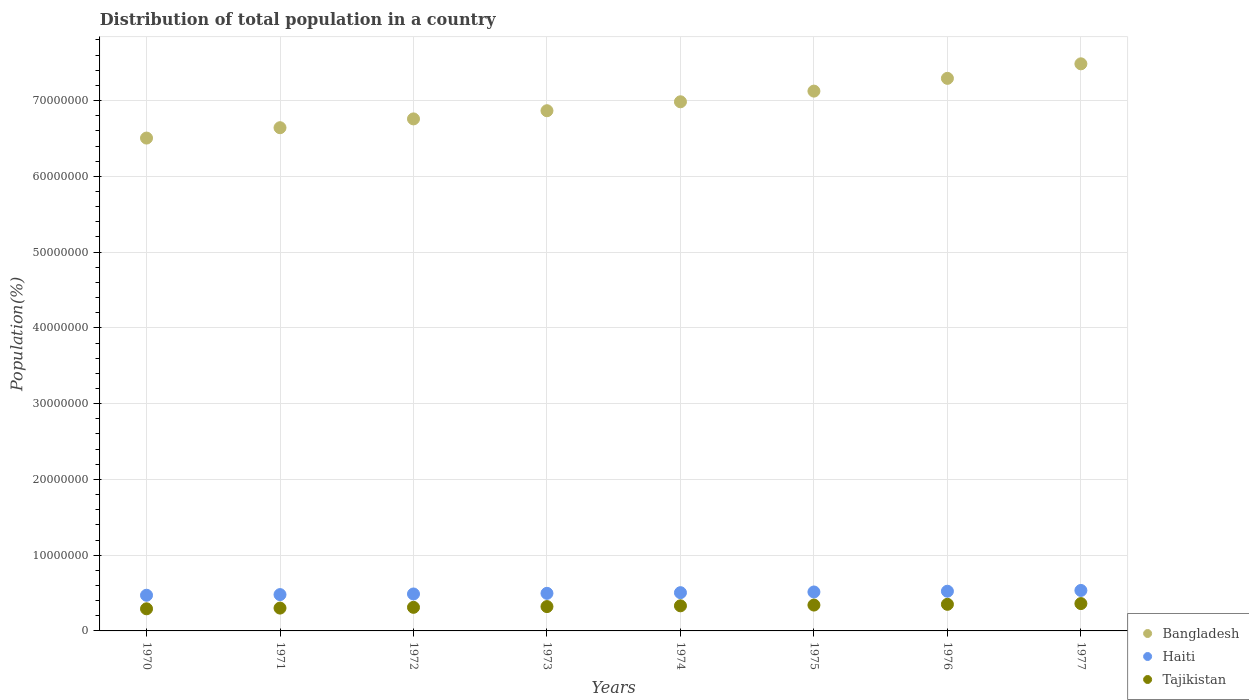How many different coloured dotlines are there?
Offer a very short reply. 3. Is the number of dotlines equal to the number of legend labels?
Offer a terse response. Yes. What is the population of in Tajikistan in 1970?
Keep it short and to the point. 2.92e+06. Across all years, what is the maximum population of in Bangladesh?
Make the answer very short. 7.48e+07. Across all years, what is the minimum population of in Bangladesh?
Your response must be concise. 6.50e+07. What is the total population of in Tajikistan in the graph?
Offer a very short reply. 2.61e+07. What is the difference between the population of in Bangladesh in 1973 and that in 1975?
Your response must be concise. -2.59e+06. What is the difference between the population of in Bangladesh in 1973 and the population of in Tajikistan in 1970?
Keep it short and to the point. 6.57e+07. What is the average population of in Bangladesh per year?
Make the answer very short. 6.96e+07. In the year 1974, what is the difference between the population of in Tajikistan and population of in Bangladesh?
Provide a short and direct response. -6.65e+07. What is the ratio of the population of in Bangladesh in 1972 to that in 1974?
Give a very brief answer. 0.97. What is the difference between the highest and the second highest population of in Bangladesh?
Your answer should be compact. 1.92e+06. What is the difference between the highest and the lowest population of in Tajikistan?
Provide a succinct answer. 6.89e+05. In how many years, is the population of in Haiti greater than the average population of in Haiti taken over all years?
Your answer should be very brief. 4. Is it the case that in every year, the sum of the population of in Tajikistan and population of in Haiti  is greater than the population of in Bangladesh?
Give a very brief answer. No. Is the population of in Haiti strictly less than the population of in Bangladesh over the years?
Keep it short and to the point. Yes. How many dotlines are there?
Your response must be concise. 3. What is the difference between two consecutive major ticks on the Y-axis?
Provide a short and direct response. 1.00e+07. Are the values on the major ticks of Y-axis written in scientific E-notation?
Keep it short and to the point. No. Does the graph contain any zero values?
Provide a succinct answer. No. What is the title of the graph?
Ensure brevity in your answer.  Distribution of total population in a country. Does "Philippines" appear as one of the legend labels in the graph?
Provide a short and direct response. No. What is the label or title of the Y-axis?
Provide a succinct answer. Population(%). What is the Population(%) of Bangladesh in 1970?
Your answer should be very brief. 6.50e+07. What is the Population(%) in Haiti in 1970?
Make the answer very short. 4.71e+06. What is the Population(%) of Tajikistan in 1970?
Ensure brevity in your answer.  2.92e+06. What is the Population(%) in Bangladesh in 1971?
Your response must be concise. 6.64e+07. What is the Population(%) of Haiti in 1971?
Your answer should be very brief. 4.79e+06. What is the Population(%) in Tajikistan in 1971?
Give a very brief answer. 3.01e+06. What is the Population(%) of Bangladesh in 1972?
Make the answer very short. 6.76e+07. What is the Population(%) in Haiti in 1972?
Keep it short and to the point. 4.88e+06. What is the Population(%) of Tajikistan in 1972?
Provide a succinct answer. 3.11e+06. What is the Population(%) in Bangladesh in 1973?
Make the answer very short. 6.87e+07. What is the Population(%) in Haiti in 1973?
Ensure brevity in your answer.  4.96e+06. What is the Population(%) of Tajikistan in 1973?
Keep it short and to the point. 3.21e+06. What is the Population(%) of Bangladesh in 1974?
Keep it short and to the point. 6.98e+07. What is the Population(%) in Haiti in 1974?
Offer a terse response. 5.05e+06. What is the Population(%) in Tajikistan in 1974?
Offer a very short reply. 3.31e+06. What is the Population(%) of Bangladesh in 1975?
Keep it short and to the point. 7.12e+07. What is the Population(%) in Haiti in 1975?
Offer a very short reply. 5.14e+06. What is the Population(%) of Tajikistan in 1975?
Offer a terse response. 3.41e+06. What is the Population(%) of Bangladesh in 1976?
Provide a succinct answer. 7.29e+07. What is the Population(%) of Haiti in 1976?
Your answer should be compact. 5.24e+06. What is the Population(%) in Tajikistan in 1976?
Give a very brief answer. 3.51e+06. What is the Population(%) in Bangladesh in 1977?
Offer a terse response. 7.48e+07. What is the Population(%) of Haiti in 1977?
Give a very brief answer. 5.34e+06. What is the Population(%) of Tajikistan in 1977?
Ensure brevity in your answer.  3.61e+06. Across all years, what is the maximum Population(%) of Bangladesh?
Give a very brief answer. 7.48e+07. Across all years, what is the maximum Population(%) in Haiti?
Your answer should be very brief. 5.34e+06. Across all years, what is the maximum Population(%) in Tajikistan?
Your answer should be compact. 3.61e+06. Across all years, what is the minimum Population(%) in Bangladesh?
Keep it short and to the point. 6.50e+07. Across all years, what is the minimum Population(%) in Haiti?
Make the answer very short. 4.71e+06. Across all years, what is the minimum Population(%) in Tajikistan?
Offer a very short reply. 2.92e+06. What is the total Population(%) of Bangladesh in the graph?
Keep it short and to the point. 5.57e+08. What is the total Population(%) in Haiti in the graph?
Provide a short and direct response. 4.01e+07. What is the total Population(%) of Tajikistan in the graph?
Offer a very short reply. 2.61e+07. What is the difference between the Population(%) in Bangladesh in 1970 and that in 1971?
Offer a very short reply. -1.37e+06. What is the difference between the Population(%) of Haiti in 1970 and that in 1971?
Make the answer very short. -8.45e+04. What is the difference between the Population(%) of Tajikistan in 1970 and that in 1971?
Your response must be concise. -9.44e+04. What is the difference between the Population(%) in Bangladesh in 1970 and that in 1972?
Offer a very short reply. -2.53e+06. What is the difference between the Population(%) in Haiti in 1970 and that in 1972?
Provide a succinct answer. -1.68e+05. What is the difference between the Population(%) of Tajikistan in 1970 and that in 1972?
Make the answer very short. -1.92e+05. What is the difference between the Population(%) of Bangladesh in 1970 and that in 1973?
Ensure brevity in your answer.  -3.61e+06. What is the difference between the Population(%) in Haiti in 1970 and that in 1973?
Your answer should be very brief. -2.52e+05. What is the difference between the Population(%) in Tajikistan in 1970 and that in 1973?
Provide a short and direct response. -2.93e+05. What is the difference between the Population(%) in Bangladesh in 1970 and that in 1974?
Provide a short and direct response. -4.79e+06. What is the difference between the Population(%) of Haiti in 1970 and that in 1974?
Provide a succinct answer. -3.39e+05. What is the difference between the Population(%) of Tajikistan in 1970 and that in 1974?
Provide a succinct answer. -3.94e+05. What is the difference between the Population(%) in Bangladesh in 1970 and that in 1975?
Provide a succinct answer. -6.20e+06. What is the difference between the Population(%) of Haiti in 1970 and that in 1975?
Give a very brief answer. -4.32e+05. What is the difference between the Population(%) in Tajikistan in 1970 and that in 1975?
Your answer should be compact. -4.93e+05. What is the difference between the Population(%) in Bangladesh in 1970 and that in 1976?
Your answer should be compact. -7.88e+06. What is the difference between the Population(%) of Haiti in 1970 and that in 1976?
Offer a very short reply. -5.30e+05. What is the difference between the Population(%) of Tajikistan in 1970 and that in 1976?
Your answer should be very brief. -5.91e+05. What is the difference between the Population(%) of Bangladesh in 1970 and that in 1977?
Give a very brief answer. -9.80e+06. What is the difference between the Population(%) in Haiti in 1970 and that in 1977?
Provide a short and direct response. -6.33e+05. What is the difference between the Population(%) in Tajikistan in 1970 and that in 1977?
Give a very brief answer. -6.89e+05. What is the difference between the Population(%) in Bangladesh in 1971 and that in 1972?
Offer a terse response. -1.16e+06. What is the difference between the Population(%) in Haiti in 1971 and that in 1972?
Make the answer very short. -8.34e+04. What is the difference between the Population(%) of Tajikistan in 1971 and that in 1972?
Keep it short and to the point. -9.81e+04. What is the difference between the Population(%) of Bangladesh in 1971 and that in 1973?
Your answer should be compact. -2.24e+06. What is the difference between the Population(%) of Haiti in 1971 and that in 1973?
Ensure brevity in your answer.  -1.67e+05. What is the difference between the Population(%) of Tajikistan in 1971 and that in 1973?
Provide a succinct answer. -1.98e+05. What is the difference between the Population(%) in Bangladesh in 1971 and that in 1974?
Offer a very short reply. -3.42e+06. What is the difference between the Population(%) in Haiti in 1971 and that in 1974?
Give a very brief answer. -2.55e+05. What is the difference between the Population(%) in Tajikistan in 1971 and that in 1974?
Offer a very short reply. -2.99e+05. What is the difference between the Population(%) of Bangladesh in 1971 and that in 1975?
Offer a very short reply. -4.83e+06. What is the difference between the Population(%) of Haiti in 1971 and that in 1975?
Your answer should be compact. -3.47e+05. What is the difference between the Population(%) of Tajikistan in 1971 and that in 1975?
Provide a succinct answer. -3.99e+05. What is the difference between the Population(%) in Bangladesh in 1971 and that in 1976?
Offer a very short reply. -6.51e+06. What is the difference between the Population(%) of Haiti in 1971 and that in 1976?
Give a very brief answer. -4.45e+05. What is the difference between the Population(%) in Tajikistan in 1971 and that in 1976?
Your answer should be very brief. -4.97e+05. What is the difference between the Population(%) in Bangladesh in 1971 and that in 1977?
Provide a succinct answer. -8.43e+06. What is the difference between the Population(%) in Haiti in 1971 and that in 1977?
Your answer should be compact. -5.48e+05. What is the difference between the Population(%) of Tajikistan in 1971 and that in 1977?
Offer a very short reply. -5.95e+05. What is the difference between the Population(%) in Bangladesh in 1972 and that in 1973?
Make the answer very short. -1.08e+06. What is the difference between the Population(%) of Haiti in 1972 and that in 1973?
Keep it short and to the point. -8.41e+04. What is the difference between the Population(%) of Tajikistan in 1972 and that in 1973?
Make the answer very short. -1.00e+05. What is the difference between the Population(%) in Bangladesh in 1972 and that in 1974?
Provide a succinct answer. -2.26e+06. What is the difference between the Population(%) in Haiti in 1972 and that in 1974?
Offer a terse response. -1.71e+05. What is the difference between the Population(%) of Tajikistan in 1972 and that in 1974?
Offer a terse response. -2.01e+05. What is the difference between the Population(%) in Bangladesh in 1972 and that in 1975?
Offer a very short reply. -3.67e+06. What is the difference between the Population(%) in Haiti in 1972 and that in 1975?
Your answer should be compact. -2.64e+05. What is the difference between the Population(%) in Tajikistan in 1972 and that in 1975?
Keep it short and to the point. -3.01e+05. What is the difference between the Population(%) of Bangladesh in 1972 and that in 1976?
Provide a succinct answer. -5.35e+06. What is the difference between the Population(%) in Haiti in 1972 and that in 1976?
Offer a very short reply. -3.62e+05. What is the difference between the Population(%) in Tajikistan in 1972 and that in 1976?
Give a very brief answer. -3.99e+05. What is the difference between the Population(%) in Bangladesh in 1972 and that in 1977?
Your answer should be compact. -7.27e+06. What is the difference between the Population(%) of Haiti in 1972 and that in 1977?
Give a very brief answer. -4.65e+05. What is the difference between the Population(%) of Tajikistan in 1972 and that in 1977?
Offer a terse response. -4.97e+05. What is the difference between the Population(%) of Bangladesh in 1973 and that in 1974?
Offer a very short reply. -1.18e+06. What is the difference between the Population(%) in Haiti in 1973 and that in 1974?
Your answer should be very brief. -8.73e+04. What is the difference between the Population(%) in Tajikistan in 1973 and that in 1974?
Your response must be concise. -1.01e+05. What is the difference between the Population(%) in Bangladesh in 1973 and that in 1975?
Offer a terse response. -2.59e+06. What is the difference between the Population(%) in Haiti in 1973 and that in 1975?
Provide a succinct answer. -1.80e+05. What is the difference between the Population(%) of Tajikistan in 1973 and that in 1975?
Make the answer very short. -2.00e+05. What is the difference between the Population(%) of Bangladesh in 1973 and that in 1976?
Your response must be concise. -4.27e+06. What is the difference between the Population(%) in Haiti in 1973 and that in 1976?
Your answer should be compact. -2.78e+05. What is the difference between the Population(%) in Tajikistan in 1973 and that in 1976?
Give a very brief answer. -2.99e+05. What is the difference between the Population(%) of Bangladesh in 1973 and that in 1977?
Ensure brevity in your answer.  -6.19e+06. What is the difference between the Population(%) of Haiti in 1973 and that in 1977?
Provide a short and direct response. -3.81e+05. What is the difference between the Population(%) of Tajikistan in 1973 and that in 1977?
Give a very brief answer. -3.96e+05. What is the difference between the Population(%) of Bangladesh in 1974 and that in 1975?
Make the answer very short. -1.41e+06. What is the difference between the Population(%) of Haiti in 1974 and that in 1975?
Your answer should be very brief. -9.24e+04. What is the difference between the Population(%) of Tajikistan in 1974 and that in 1975?
Offer a terse response. -9.97e+04. What is the difference between the Population(%) of Bangladesh in 1974 and that in 1976?
Ensure brevity in your answer.  -3.09e+06. What is the difference between the Population(%) in Haiti in 1974 and that in 1976?
Keep it short and to the point. -1.90e+05. What is the difference between the Population(%) in Tajikistan in 1974 and that in 1976?
Provide a short and direct response. -1.98e+05. What is the difference between the Population(%) in Bangladesh in 1974 and that in 1977?
Your response must be concise. -5.01e+06. What is the difference between the Population(%) of Haiti in 1974 and that in 1977?
Give a very brief answer. -2.93e+05. What is the difference between the Population(%) of Tajikistan in 1974 and that in 1977?
Give a very brief answer. -2.96e+05. What is the difference between the Population(%) in Bangladesh in 1975 and that in 1976?
Your response must be concise. -1.68e+06. What is the difference between the Population(%) of Haiti in 1975 and that in 1976?
Provide a succinct answer. -9.79e+04. What is the difference between the Population(%) of Tajikistan in 1975 and that in 1976?
Make the answer very short. -9.82e+04. What is the difference between the Population(%) in Bangladesh in 1975 and that in 1977?
Your answer should be very brief. -3.60e+06. What is the difference between the Population(%) of Haiti in 1975 and that in 1977?
Offer a terse response. -2.01e+05. What is the difference between the Population(%) in Tajikistan in 1975 and that in 1977?
Offer a very short reply. -1.96e+05. What is the difference between the Population(%) of Bangladesh in 1976 and that in 1977?
Your answer should be very brief. -1.92e+06. What is the difference between the Population(%) of Haiti in 1976 and that in 1977?
Offer a very short reply. -1.03e+05. What is the difference between the Population(%) of Tajikistan in 1976 and that in 1977?
Offer a terse response. -9.77e+04. What is the difference between the Population(%) of Bangladesh in 1970 and the Population(%) of Haiti in 1971?
Make the answer very short. 6.03e+07. What is the difference between the Population(%) in Bangladesh in 1970 and the Population(%) in Tajikistan in 1971?
Ensure brevity in your answer.  6.20e+07. What is the difference between the Population(%) in Haiti in 1970 and the Population(%) in Tajikistan in 1971?
Your answer should be compact. 1.69e+06. What is the difference between the Population(%) in Bangladesh in 1970 and the Population(%) in Haiti in 1972?
Ensure brevity in your answer.  6.02e+07. What is the difference between the Population(%) of Bangladesh in 1970 and the Population(%) of Tajikistan in 1972?
Give a very brief answer. 6.19e+07. What is the difference between the Population(%) of Haiti in 1970 and the Population(%) of Tajikistan in 1972?
Offer a very short reply. 1.60e+06. What is the difference between the Population(%) of Bangladesh in 1970 and the Population(%) of Haiti in 1973?
Offer a terse response. 6.01e+07. What is the difference between the Population(%) in Bangladesh in 1970 and the Population(%) in Tajikistan in 1973?
Provide a short and direct response. 6.18e+07. What is the difference between the Population(%) in Haiti in 1970 and the Population(%) in Tajikistan in 1973?
Give a very brief answer. 1.50e+06. What is the difference between the Population(%) of Bangladesh in 1970 and the Population(%) of Haiti in 1974?
Offer a very short reply. 6.00e+07. What is the difference between the Population(%) of Bangladesh in 1970 and the Population(%) of Tajikistan in 1974?
Provide a succinct answer. 6.17e+07. What is the difference between the Population(%) in Haiti in 1970 and the Population(%) in Tajikistan in 1974?
Offer a very short reply. 1.40e+06. What is the difference between the Population(%) in Bangladesh in 1970 and the Population(%) in Haiti in 1975?
Make the answer very short. 5.99e+07. What is the difference between the Population(%) in Bangladesh in 1970 and the Population(%) in Tajikistan in 1975?
Keep it short and to the point. 6.16e+07. What is the difference between the Population(%) of Haiti in 1970 and the Population(%) of Tajikistan in 1975?
Your response must be concise. 1.30e+06. What is the difference between the Population(%) in Bangladesh in 1970 and the Population(%) in Haiti in 1976?
Ensure brevity in your answer.  5.98e+07. What is the difference between the Population(%) in Bangladesh in 1970 and the Population(%) in Tajikistan in 1976?
Ensure brevity in your answer.  6.15e+07. What is the difference between the Population(%) in Haiti in 1970 and the Population(%) in Tajikistan in 1976?
Offer a terse response. 1.20e+06. What is the difference between the Population(%) of Bangladesh in 1970 and the Population(%) of Haiti in 1977?
Ensure brevity in your answer.  5.97e+07. What is the difference between the Population(%) in Bangladesh in 1970 and the Population(%) in Tajikistan in 1977?
Offer a very short reply. 6.14e+07. What is the difference between the Population(%) in Haiti in 1970 and the Population(%) in Tajikistan in 1977?
Offer a terse response. 1.10e+06. What is the difference between the Population(%) of Bangladesh in 1971 and the Population(%) of Haiti in 1972?
Your answer should be very brief. 6.15e+07. What is the difference between the Population(%) in Bangladesh in 1971 and the Population(%) in Tajikistan in 1972?
Keep it short and to the point. 6.33e+07. What is the difference between the Population(%) of Haiti in 1971 and the Population(%) of Tajikistan in 1972?
Keep it short and to the point. 1.68e+06. What is the difference between the Population(%) of Bangladesh in 1971 and the Population(%) of Haiti in 1973?
Your answer should be very brief. 6.15e+07. What is the difference between the Population(%) of Bangladesh in 1971 and the Population(%) of Tajikistan in 1973?
Keep it short and to the point. 6.32e+07. What is the difference between the Population(%) in Haiti in 1971 and the Population(%) in Tajikistan in 1973?
Your answer should be very brief. 1.58e+06. What is the difference between the Population(%) in Bangladesh in 1971 and the Population(%) in Haiti in 1974?
Give a very brief answer. 6.14e+07. What is the difference between the Population(%) of Bangladesh in 1971 and the Population(%) of Tajikistan in 1974?
Your answer should be compact. 6.31e+07. What is the difference between the Population(%) of Haiti in 1971 and the Population(%) of Tajikistan in 1974?
Your answer should be compact. 1.48e+06. What is the difference between the Population(%) of Bangladesh in 1971 and the Population(%) of Haiti in 1975?
Give a very brief answer. 6.13e+07. What is the difference between the Population(%) in Bangladesh in 1971 and the Population(%) in Tajikistan in 1975?
Offer a terse response. 6.30e+07. What is the difference between the Population(%) of Haiti in 1971 and the Population(%) of Tajikistan in 1975?
Keep it short and to the point. 1.38e+06. What is the difference between the Population(%) of Bangladesh in 1971 and the Population(%) of Haiti in 1976?
Make the answer very short. 6.12e+07. What is the difference between the Population(%) in Bangladesh in 1971 and the Population(%) in Tajikistan in 1976?
Keep it short and to the point. 6.29e+07. What is the difference between the Population(%) of Haiti in 1971 and the Population(%) of Tajikistan in 1976?
Your answer should be compact. 1.28e+06. What is the difference between the Population(%) in Bangladesh in 1971 and the Population(%) in Haiti in 1977?
Offer a very short reply. 6.11e+07. What is the difference between the Population(%) of Bangladesh in 1971 and the Population(%) of Tajikistan in 1977?
Your answer should be very brief. 6.28e+07. What is the difference between the Population(%) of Haiti in 1971 and the Population(%) of Tajikistan in 1977?
Give a very brief answer. 1.18e+06. What is the difference between the Population(%) of Bangladesh in 1972 and the Population(%) of Haiti in 1973?
Make the answer very short. 6.26e+07. What is the difference between the Population(%) in Bangladesh in 1972 and the Population(%) in Tajikistan in 1973?
Make the answer very short. 6.44e+07. What is the difference between the Population(%) in Haiti in 1972 and the Population(%) in Tajikistan in 1973?
Provide a succinct answer. 1.66e+06. What is the difference between the Population(%) of Bangladesh in 1972 and the Population(%) of Haiti in 1974?
Your answer should be very brief. 6.25e+07. What is the difference between the Population(%) of Bangladesh in 1972 and the Population(%) of Tajikistan in 1974?
Your response must be concise. 6.43e+07. What is the difference between the Population(%) in Haiti in 1972 and the Population(%) in Tajikistan in 1974?
Offer a terse response. 1.56e+06. What is the difference between the Population(%) of Bangladesh in 1972 and the Population(%) of Haiti in 1975?
Offer a very short reply. 6.24e+07. What is the difference between the Population(%) in Bangladesh in 1972 and the Population(%) in Tajikistan in 1975?
Ensure brevity in your answer.  6.42e+07. What is the difference between the Population(%) in Haiti in 1972 and the Population(%) in Tajikistan in 1975?
Your response must be concise. 1.46e+06. What is the difference between the Population(%) in Bangladesh in 1972 and the Population(%) in Haiti in 1976?
Ensure brevity in your answer.  6.23e+07. What is the difference between the Population(%) in Bangladesh in 1972 and the Population(%) in Tajikistan in 1976?
Your answer should be compact. 6.41e+07. What is the difference between the Population(%) in Haiti in 1972 and the Population(%) in Tajikistan in 1976?
Make the answer very short. 1.37e+06. What is the difference between the Population(%) of Bangladesh in 1972 and the Population(%) of Haiti in 1977?
Ensure brevity in your answer.  6.22e+07. What is the difference between the Population(%) in Bangladesh in 1972 and the Population(%) in Tajikistan in 1977?
Provide a succinct answer. 6.40e+07. What is the difference between the Population(%) in Haiti in 1972 and the Population(%) in Tajikistan in 1977?
Your answer should be very brief. 1.27e+06. What is the difference between the Population(%) of Bangladesh in 1973 and the Population(%) of Haiti in 1974?
Offer a very short reply. 6.36e+07. What is the difference between the Population(%) in Bangladesh in 1973 and the Population(%) in Tajikistan in 1974?
Your answer should be very brief. 6.53e+07. What is the difference between the Population(%) of Haiti in 1973 and the Population(%) of Tajikistan in 1974?
Ensure brevity in your answer.  1.65e+06. What is the difference between the Population(%) in Bangladesh in 1973 and the Population(%) in Haiti in 1975?
Provide a short and direct response. 6.35e+07. What is the difference between the Population(%) of Bangladesh in 1973 and the Population(%) of Tajikistan in 1975?
Offer a terse response. 6.52e+07. What is the difference between the Population(%) of Haiti in 1973 and the Population(%) of Tajikistan in 1975?
Offer a terse response. 1.55e+06. What is the difference between the Population(%) of Bangladesh in 1973 and the Population(%) of Haiti in 1976?
Keep it short and to the point. 6.34e+07. What is the difference between the Population(%) of Bangladesh in 1973 and the Population(%) of Tajikistan in 1976?
Ensure brevity in your answer.  6.51e+07. What is the difference between the Population(%) of Haiti in 1973 and the Population(%) of Tajikistan in 1976?
Your response must be concise. 1.45e+06. What is the difference between the Population(%) of Bangladesh in 1973 and the Population(%) of Haiti in 1977?
Provide a short and direct response. 6.33e+07. What is the difference between the Population(%) of Bangladesh in 1973 and the Population(%) of Tajikistan in 1977?
Offer a terse response. 6.50e+07. What is the difference between the Population(%) of Haiti in 1973 and the Population(%) of Tajikistan in 1977?
Make the answer very short. 1.35e+06. What is the difference between the Population(%) of Bangladesh in 1974 and the Population(%) of Haiti in 1975?
Your answer should be very brief. 6.47e+07. What is the difference between the Population(%) of Bangladesh in 1974 and the Population(%) of Tajikistan in 1975?
Your answer should be very brief. 6.64e+07. What is the difference between the Population(%) of Haiti in 1974 and the Population(%) of Tajikistan in 1975?
Ensure brevity in your answer.  1.64e+06. What is the difference between the Population(%) in Bangladesh in 1974 and the Population(%) in Haiti in 1976?
Your response must be concise. 6.46e+07. What is the difference between the Population(%) of Bangladesh in 1974 and the Population(%) of Tajikistan in 1976?
Your answer should be compact. 6.63e+07. What is the difference between the Population(%) of Haiti in 1974 and the Population(%) of Tajikistan in 1976?
Keep it short and to the point. 1.54e+06. What is the difference between the Population(%) of Bangladesh in 1974 and the Population(%) of Haiti in 1977?
Keep it short and to the point. 6.45e+07. What is the difference between the Population(%) of Bangladesh in 1974 and the Population(%) of Tajikistan in 1977?
Provide a short and direct response. 6.62e+07. What is the difference between the Population(%) of Haiti in 1974 and the Population(%) of Tajikistan in 1977?
Ensure brevity in your answer.  1.44e+06. What is the difference between the Population(%) in Bangladesh in 1975 and the Population(%) in Haiti in 1976?
Your response must be concise. 6.60e+07. What is the difference between the Population(%) of Bangladesh in 1975 and the Population(%) of Tajikistan in 1976?
Your answer should be very brief. 6.77e+07. What is the difference between the Population(%) in Haiti in 1975 and the Population(%) in Tajikistan in 1976?
Make the answer very short. 1.63e+06. What is the difference between the Population(%) in Bangladesh in 1975 and the Population(%) in Haiti in 1977?
Provide a succinct answer. 6.59e+07. What is the difference between the Population(%) of Bangladesh in 1975 and the Population(%) of Tajikistan in 1977?
Provide a short and direct response. 6.76e+07. What is the difference between the Population(%) in Haiti in 1975 and the Population(%) in Tajikistan in 1977?
Keep it short and to the point. 1.53e+06. What is the difference between the Population(%) in Bangladesh in 1976 and the Population(%) in Haiti in 1977?
Your response must be concise. 6.76e+07. What is the difference between the Population(%) of Bangladesh in 1976 and the Population(%) of Tajikistan in 1977?
Offer a terse response. 6.93e+07. What is the difference between the Population(%) of Haiti in 1976 and the Population(%) of Tajikistan in 1977?
Your response must be concise. 1.63e+06. What is the average Population(%) of Bangladesh per year?
Your answer should be compact. 6.96e+07. What is the average Population(%) in Haiti per year?
Ensure brevity in your answer.  5.01e+06. What is the average Population(%) in Tajikistan per year?
Ensure brevity in your answer.  3.26e+06. In the year 1970, what is the difference between the Population(%) in Bangladesh and Population(%) in Haiti?
Keep it short and to the point. 6.03e+07. In the year 1970, what is the difference between the Population(%) in Bangladesh and Population(%) in Tajikistan?
Keep it short and to the point. 6.21e+07. In the year 1970, what is the difference between the Population(%) in Haiti and Population(%) in Tajikistan?
Offer a very short reply. 1.79e+06. In the year 1971, what is the difference between the Population(%) in Bangladesh and Population(%) in Haiti?
Provide a succinct answer. 6.16e+07. In the year 1971, what is the difference between the Population(%) in Bangladesh and Population(%) in Tajikistan?
Keep it short and to the point. 6.34e+07. In the year 1971, what is the difference between the Population(%) of Haiti and Population(%) of Tajikistan?
Provide a short and direct response. 1.78e+06. In the year 1972, what is the difference between the Population(%) of Bangladesh and Population(%) of Haiti?
Your answer should be compact. 6.27e+07. In the year 1972, what is the difference between the Population(%) in Bangladesh and Population(%) in Tajikistan?
Your answer should be very brief. 6.45e+07. In the year 1972, what is the difference between the Population(%) in Haiti and Population(%) in Tajikistan?
Your answer should be very brief. 1.76e+06. In the year 1973, what is the difference between the Population(%) in Bangladesh and Population(%) in Haiti?
Offer a very short reply. 6.37e+07. In the year 1973, what is the difference between the Population(%) in Bangladesh and Population(%) in Tajikistan?
Your response must be concise. 6.54e+07. In the year 1973, what is the difference between the Population(%) in Haiti and Population(%) in Tajikistan?
Provide a short and direct response. 1.75e+06. In the year 1974, what is the difference between the Population(%) in Bangladesh and Population(%) in Haiti?
Provide a short and direct response. 6.48e+07. In the year 1974, what is the difference between the Population(%) in Bangladesh and Population(%) in Tajikistan?
Offer a terse response. 6.65e+07. In the year 1974, what is the difference between the Population(%) in Haiti and Population(%) in Tajikistan?
Give a very brief answer. 1.73e+06. In the year 1975, what is the difference between the Population(%) in Bangladesh and Population(%) in Haiti?
Your answer should be very brief. 6.61e+07. In the year 1975, what is the difference between the Population(%) in Bangladesh and Population(%) in Tajikistan?
Your answer should be compact. 6.78e+07. In the year 1975, what is the difference between the Population(%) in Haiti and Population(%) in Tajikistan?
Your answer should be compact. 1.73e+06. In the year 1976, what is the difference between the Population(%) in Bangladesh and Population(%) in Haiti?
Offer a terse response. 6.77e+07. In the year 1976, what is the difference between the Population(%) in Bangladesh and Population(%) in Tajikistan?
Ensure brevity in your answer.  6.94e+07. In the year 1976, what is the difference between the Population(%) of Haiti and Population(%) of Tajikistan?
Provide a succinct answer. 1.73e+06. In the year 1977, what is the difference between the Population(%) in Bangladesh and Population(%) in Haiti?
Offer a very short reply. 6.95e+07. In the year 1977, what is the difference between the Population(%) of Bangladesh and Population(%) of Tajikistan?
Offer a terse response. 7.12e+07. In the year 1977, what is the difference between the Population(%) in Haiti and Population(%) in Tajikistan?
Provide a succinct answer. 1.73e+06. What is the ratio of the Population(%) of Bangladesh in 1970 to that in 1971?
Your response must be concise. 0.98. What is the ratio of the Population(%) in Haiti in 1970 to that in 1971?
Ensure brevity in your answer.  0.98. What is the ratio of the Population(%) of Tajikistan in 1970 to that in 1971?
Your answer should be very brief. 0.97. What is the ratio of the Population(%) of Bangladesh in 1970 to that in 1972?
Provide a succinct answer. 0.96. What is the ratio of the Population(%) in Haiti in 1970 to that in 1972?
Offer a very short reply. 0.97. What is the ratio of the Population(%) of Tajikistan in 1970 to that in 1972?
Provide a short and direct response. 0.94. What is the ratio of the Population(%) of Bangladesh in 1970 to that in 1973?
Your answer should be very brief. 0.95. What is the ratio of the Population(%) of Haiti in 1970 to that in 1973?
Your answer should be compact. 0.95. What is the ratio of the Population(%) in Tajikistan in 1970 to that in 1973?
Offer a very short reply. 0.91. What is the ratio of the Population(%) of Bangladesh in 1970 to that in 1974?
Your answer should be very brief. 0.93. What is the ratio of the Population(%) in Haiti in 1970 to that in 1974?
Your response must be concise. 0.93. What is the ratio of the Population(%) of Tajikistan in 1970 to that in 1974?
Offer a terse response. 0.88. What is the ratio of the Population(%) in Haiti in 1970 to that in 1975?
Offer a very short reply. 0.92. What is the ratio of the Population(%) in Tajikistan in 1970 to that in 1975?
Give a very brief answer. 0.86. What is the ratio of the Population(%) in Bangladesh in 1970 to that in 1976?
Make the answer very short. 0.89. What is the ratio of the Population(%) in Haiti in 1970 to that in 1976?
Your answer should be very brief. 0.9. What is the ratio of the Population(%) in Tajikistan in 1970 to that in 1976?
Provide a short and direct response. 0.83. What is the ratio of the Population(%) of Bangladesh in 1970 to that in 1977?
Give a very brief answer. 0.87. What is the ratio of the Population(%) in Haiti in 1970 to that in 1977?
Your answer should be very brief. 0.88. What is the ratio of the Population(%) in Tajikistan in 1970 to that in 1977?
Make the answer very short. 0.81. What is the ratio of the Population(%) of Bangladesh in 1971 to that in 1972?
Give a very brief answer. 0.98. What is the ratio of the Population(%) of Haiti in 1971 to that in 1972?
Keep it short and to the point. 0.98. What is the ratio of the Population(%) of Tajikistan in 1971 to that in 1972?
Give a very brief answer. 0.97. What is the ratio of the Population(%) of Bangladesh in 1971 to that in 1973?
Ensure brevity in your answer.  0.97. What is the ratio of the Population(%) in Haiti in 1971 to that in 1973?
Offer a very short reply. 0.97. What is the ratio of the Population(%) of Tajikistan in 1971 to that in 1973?
Offer a very short reply. 0.94. What is the ratio of the Population(%) in Bangladesh in 1971 to that in 1974?
Your answer should be very brief. 0.95. What is the ratio of the Population(%) of Haiti in 1971 to that in 1974?
Offer a very short reply. 0.95. What is the ratio of the Population(%) in Tajikistan in 1971 to that in 1974?
Your response must be concise. 0.91. What is the ratio of the Population(%) in Bangladesh in 1971 to that in 1975?
Offer a very short reply. 0.93. What is the ratio of the Population(%) in Haiti in 1971 to that in 1975?
Your answer should be compact. 0.93. What is the ratio of the Population(%) in Tajikistan in 1971 to that in 1975?
Ensure brevity in your answer.  0.88. What is the ratio of the Population(%) of Bangladesh in 1971 to that in 1976?
Make the answer very short. 0.91. What is the ratio of the Population(%) of Haiti in 1971 to that in 1976?
Offer a terse response. 0.92. What is the ratio of the Population(%) in Tajikistan in 1971 to that in 1976?
Provide a short and direct response. 0.86. What is the ratio of the Population(%) of Bangladesh in 1971 to that in 1977?
Offer a very short reply. 0.89. What is the ratio of the Population(%) in Haiti in 1971 to that in 1977?
Offer a very short reply. 0.9. What is the ratio of the Population(%) in Tajikistan in 1971 to that in 1977?
Offer a very short reply. 0.84. What is the ratio of the Population(%) in Bangladesh in 1972 to that in 1973?
Keep it short and to the point. 0.98. What is the ratio of the Population(%) of Haiti in 1972 to that in 1973?
Provide a short and direct response. 0.98. What is the ratio of the Population(%) of Tajikistan in 1972 to that in 1973?
Offer a very short reply. 0.97. What is the ratio of the Population(%) in Bangladesh in 1972 to that in 1974?
Make the answer very short. 0.97. What is the ratio of the Population(%) of Haiti in 1972 to that in 1974?
Your answer should be very brief. 0.97. What is the ratio of the Population(%) of Tajikistan in 1972 to that in 1974?
Make the answer very short. 0.94. What is the ratio of the Population(%) of Bangladesh in 1972 to that in 1975?
Provide a short and direct response. 0.95. What is the ratio of the Population(%) of Haiti in 1972 to that in 1975?
Your answer should be very brief. 0.95. What is the ratio of the Population(%) of Tajikistan in 1972 to that in 1975?
Offer a terse response. 0.91. What is the ratio of the Population(%) of Bangladesh in 1972 to that in 1976?
Your answer should be very brief. 0.93. What is the ratio of the Population(%) in Haiti in 1972 to that in 1976?
Your answer should be compact. 0.93. What is the ratio of the Population(%) of Tajikistan in 1972 to that in 1976?
Ensure brevity in your answer.  0.89. What is the ratio of the Population(%) in Bangladesh in 1972 to that in 1977?
Keep it short and to the point. 0.9. What is the ratio of the Population(%) of Haiti in 1972 to that in 1977?
Your response must be concise. 0.91. What is the ratio of the Population(%) of Tajikistan in 1972 to that in 1977?
Your answer should be compact. 0.86. What is the ratio of the Population(%) in Bangladesh in 1973 to that in 1974?
Your response must be concise. 0.98. What is the ratio of the Population(%) in Haiti in 1973 to that in 1974?
Provide a short and direct response. 0.98. What is the ratio of the Population(%) of Tajikistan in 1973 to that in 1974?
Provide a succinct answer. 0.97. What is the ratio of the Population(%) in Bangladesh in 1973 to that in 1975?
Your answer should be very brief. 0.96. What is the ratio of the Population(%) in Tajikistan in 1973 to that in 1975?
Your answer should be very brief. 0.94. What is the ratio of the Population(%) in Bangladesh in 1973 to that in 1976?
Provide a short and direct response. 0.94. What is the ratio of the Population(%) in Haiti in 1973 to that in 1976?
Offer a terse response. 0.95. What is the ratio of the Population(%) in Tajikistan in 1973 to that in 1976?
Ensure brevity in your answer.  0.92. What is the ratio of the Population(%) of Bangladesh in 1973 to that in 1977?
Provide a succinct answer. 0.92. What is the ratio of the Population(%) of Haiti in 1973 to that in 1977?
Keep it short and to the point. 0.93. What is the ratio of the Population(%) in Tajikistan in 1973 to that in 1977?
Your response must be concise. 0.89. What is the ratio of the Population(%) in Bangladesh in 1974 to that in 1975?
Keep it short and to the point. 0.98. What is the ratio of the Population(%) of Tajikistan in 1974 to that in 1975?
Offer a terse response. 0.97. What is the ratio of the Population(%) of Bangladesh in 1974 to that in 1976?
Ensure brevity in your answer.  0.96. What is the ratio of the Population(%) in Haiti in 1974 to that in 1976?
Give a very brief answer. 0.96. What is the ratio of the Population(%) of Tajikistan in 1974 to that in 1976?
Provide a short and direct response. 0.94. What is the ratio of the Population(%) of Bangladesh in 1974 to that in 1977?
Provide a succinct answer. 0.93. What is the ratio of the Population(%) in Haiti in 1974 to that in 1977?
Your response must be concise. 0.95. What is the ratio of the Population(%) in Tajikistan in 1974 to that in 1977?
Ensure brevity in your answer.  0.92. What is the ratio of the Population(%) in Bangladesh in 1975 to that in 1976?
Make the answer very short. 0.98. What is the ratio of the Population(%) of Haiti in 1975 to that in 1976?
Offer a very short reply. 0.98. What is the ratio of the Population(%) of Bangladesh in 1975 to that in 1977?
Your response must be concise. 0.95. What is the ratio of the Population(%) of Haiti in 1975 to that in 1977?
Offer a very short reply. 0.96. What is the ratio of the Population(%) of Tajikistan in 1975 to that in 1977?
Provide a succinct answer. 0.95. What is the ratio of the Population(%) of Bangladesh in 1976 to that in 1977?
Provide a succinct answer. 0.97. What is the ratio of the Population(%) of Haiti in 1976 to that in 1977?
Offer a very short reply. 0.98. What is the ratio of the Population(%) of Tajikistan in 1976 to that in 1977?
Your response must be concise. 0.97. What is the difference between the highest and the second highest Population(%) in Bangladesh?
Give a very brief answer. 1.92e+06. What is the difference between the highest and the second highest Population(%) in Haiti?
Give a very brief answer. 1.03e+05. What is the difference between the highest and the second highest Population(%) of Tajikistan?
Offer a terse response. 9.77e+04. What is the difference between the highest and the lowest Population(%) in Bangladesh?
Keep it short and to the point. 9.80e+06. What is the difference between the highest and the lowest Population(%) of Haiti?
Your answer should be compact. 6.33e+05. What is the difference between the highest and the lowest Population(%) in Tajikistan?
Ensure brevity in your answer.  6.89e+05. 